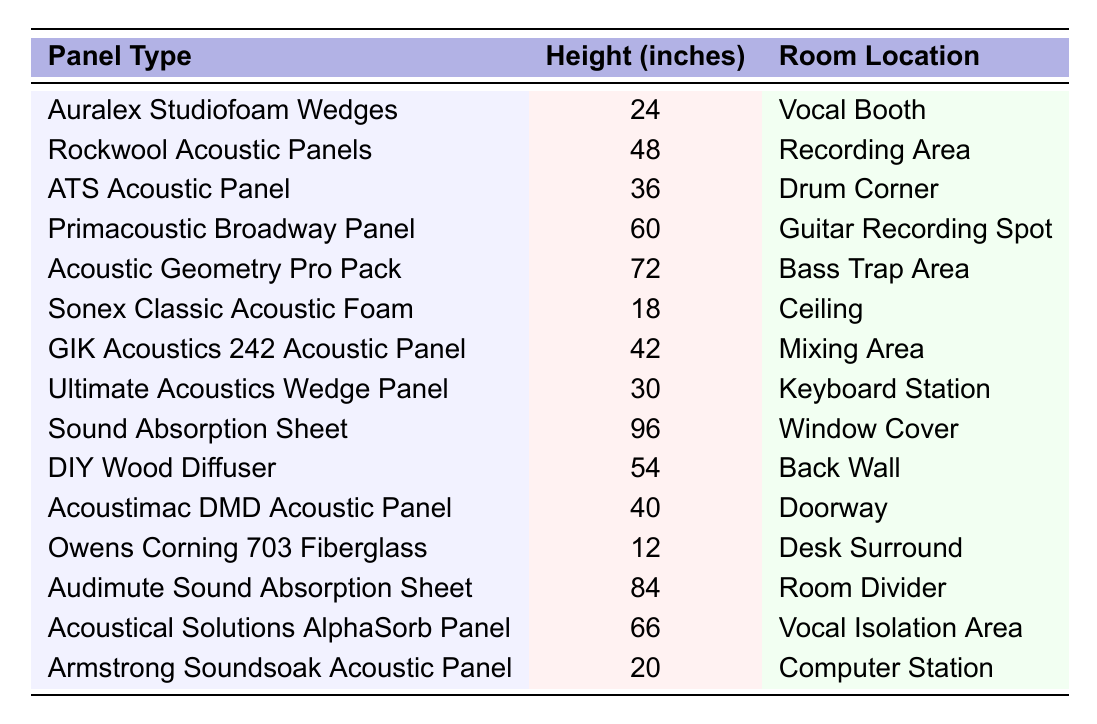What is the height of the Auralex Studiofoam Wedges? The table shows that the Auralex Studiofoam Wedges have a height measurement of 24 inches.
Answer: 24 inches Which panel has the highest height? By reviewing the height measurements listed, the Sound Absorption Sheet at 96 inches has the highest height among all the panels.
Answer: 96 inches How many acoustic panels are there with a height greater than 50 inches? Looking at the height values, the panels with heights greater than 50 inches are the Acoustic Geometry Pro Pack (72), Audimute Sound Absorption Sheet (84), and the Sound Absorption Sheet (96), totaling 3 panels.
Answer: 3 Is the Rockwool Acoustic Panel located in the Vocal Booth? The table indicates that the Rockwool Acoustic Panels are located in the Recording Area, not in the Vocal Booth.
Answer: No What is the average height of the acoustic panels listed in the table? To calculate the average, first sum all the heights: 24 + 48 + 36 + 60 + 72 + 18 + 42 + 30 + 96 + 54 + 40 + 12 + 84 + 66 + 20 =  648 inches. There are 15 panels, so the average height is 648/15 = 43.2 inches.
Answer: 43.2 inches Which panel is found in the Mixing Area and what is its height? The table indicates that the GIK Acoustics 242 Acoustic Panel is located in the Mixing Area with a height of 42 inches.
Answer: GIK Acoustics 242 Acoustic Panel, 42 inches How much taller is the Acoustic Geometry Pro Pack compared to the Sonex Classic Acoustic Foam? The Acoustic Geometry Pro Pack is 72 inches tall, while the Sonex Classic Acoustic Foam is 18 inches tall. The difference is 72 - 18 = 54 inches.
Answer: 54 inches Are there any panels that are exactly 60 inches tall? The table shows that the Primacoustic Broadway Panel is the only panel with a height of exactly 60 inches.
Answer: Yes What is the total height of the three shortest panels? The three shortest panels are: Owens Corning 703 Fiberglass at 12 inches, Sonex Classic Acoustic Foam at 18 inches, and Auralex Studiofoam Wedges at 24 inches. Their total height is 12 + 18 + 24 = 54 inches.
Answer: 54 inches Which two panels are both located in areas for musical recording and how do their heights compare? The panels located in areas for musical recording are the Rockwool Acoustic Panels (48 inches) in the Recording Area and the Primacoustic Broadway Panel (60 inches) in the Guitar Recording Spot. The Primacoustic Broadway Panel is taller by 12 inches.
Answer: Rockwool and Primacoustic, Primacoustic is taller by 12 inches 